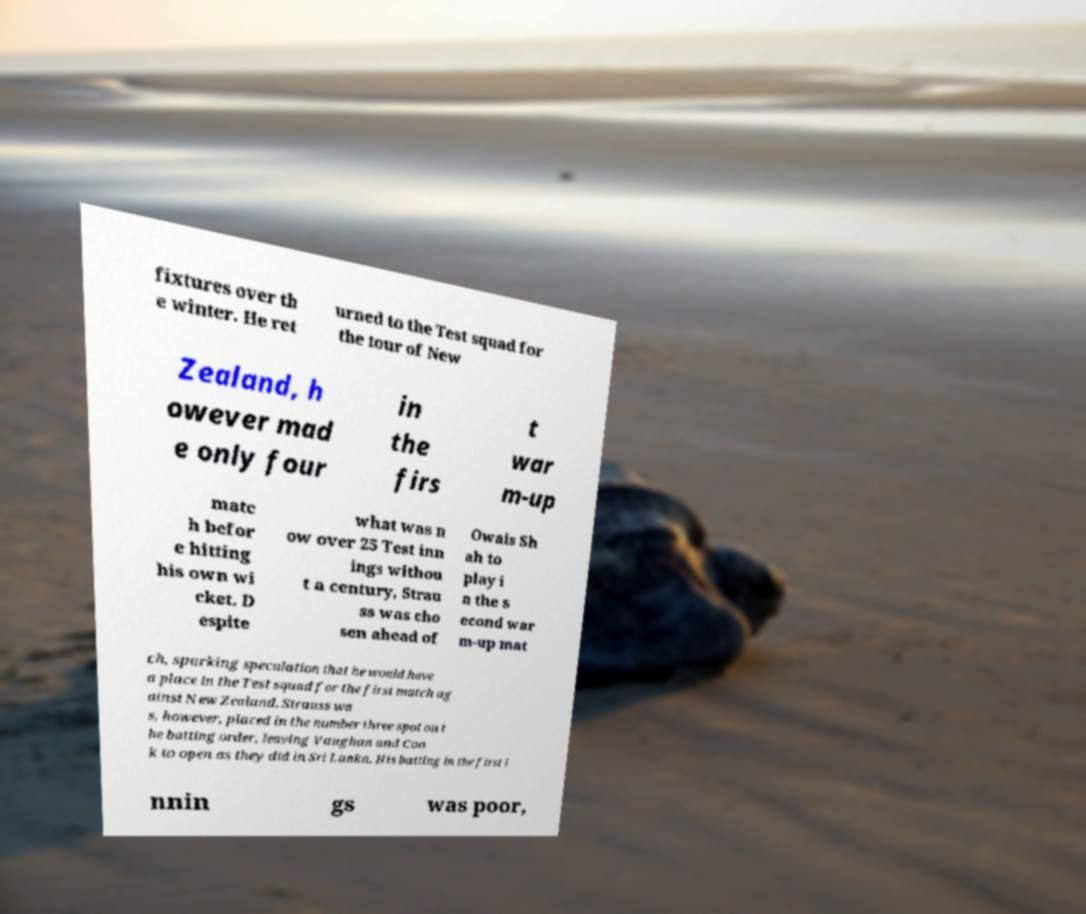There's text embedded in this image that I need extracted. Can you transcribe it verbatim? fixtures over th e winter. He ret urned to the Test squad for the tour of New Zealand, h owever mad e only four in the firs t war m-up matc h befor e hitting his own wi cket. D espite what was n ow over 25 Test inn ings withou t a century, Strau ss was cho sen ahead of Owais Sh ah to play i n the s econd war m-up mat ch, sparking speculation that he would have a place in the Test squad for the first match ag ainst New Zealand. Strauss wa s, however, placed in the number three spot on t he batting order, leaving Vaughan and Coo k to open as they did in Sri Lanka. His batting in the first i nnin gs was poor, 